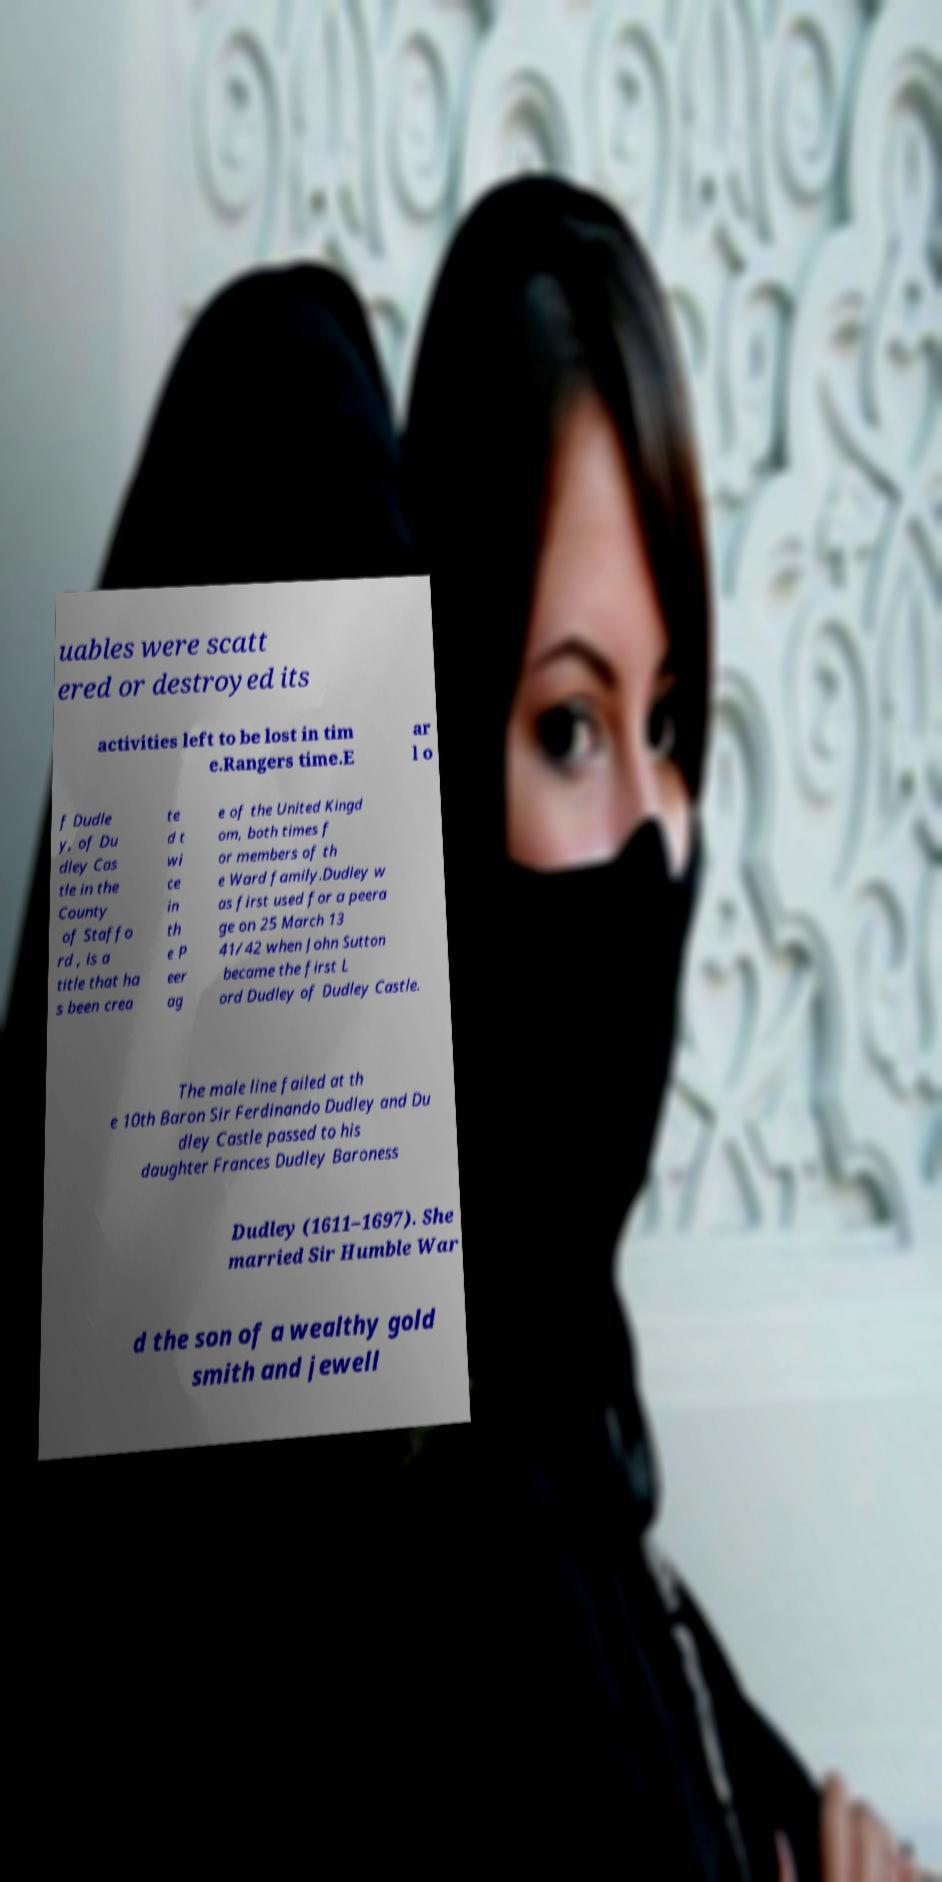Please identify and transcribe the text found in this image. uables were scatt ered or destroyed its activities left to be lost in tim e.Rangers time.E ar l o f Dudle y, of Du dley Cas tle in the County of Staffo rd , is a title that ha s been crea te d t wi ce in th e P eer ag e of the United Kingd om, both times f or members of th e Ward family.Dudley w as first used for a peera ge on 25 March 13 41/42 when John Sutton became the first L ord Dudley of Dudley Castle. The male line failed at th e 10th Baron Sir Ferdinando Dudley and Du dley Castle passed to his daughter Frances Dudley Baroness Dudley (1611–1697). She married Sir Humble War d the son of a wealthy gold smith and jewell 